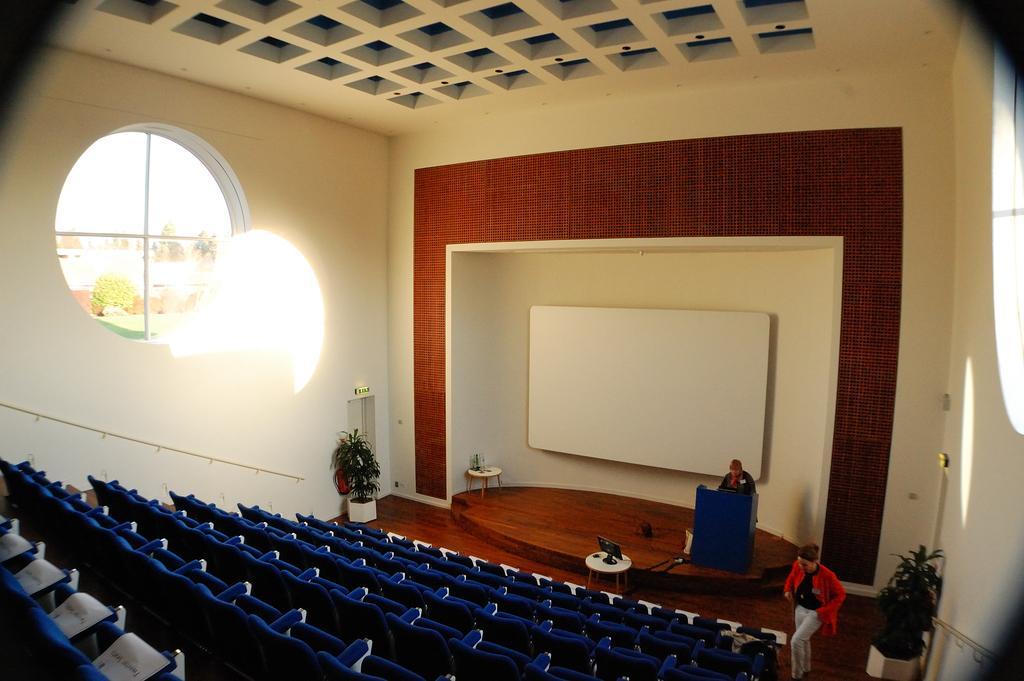Please provide a concise description of this image. This is a auditorium here we can see many chairs on the floor and there is a window,wall,house plants on the floor,a woman standing at the podium and a woman walking on the floor,laptop and water bottles on tables respectively and a screen on the wall. 